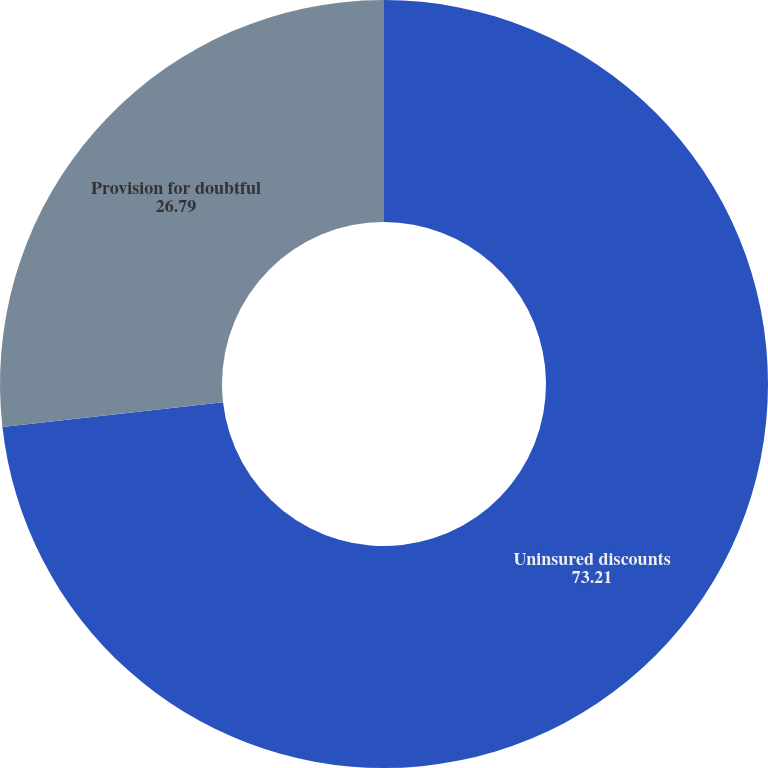Convert chart. <chart><loc_0><loc_0><loc_500><loc_500><pie_chart><fcel>Uninsured discounts<fcel>Provision for doubtful<nl><fcel>73.21%<fcel>26.79%<nl></chart> 